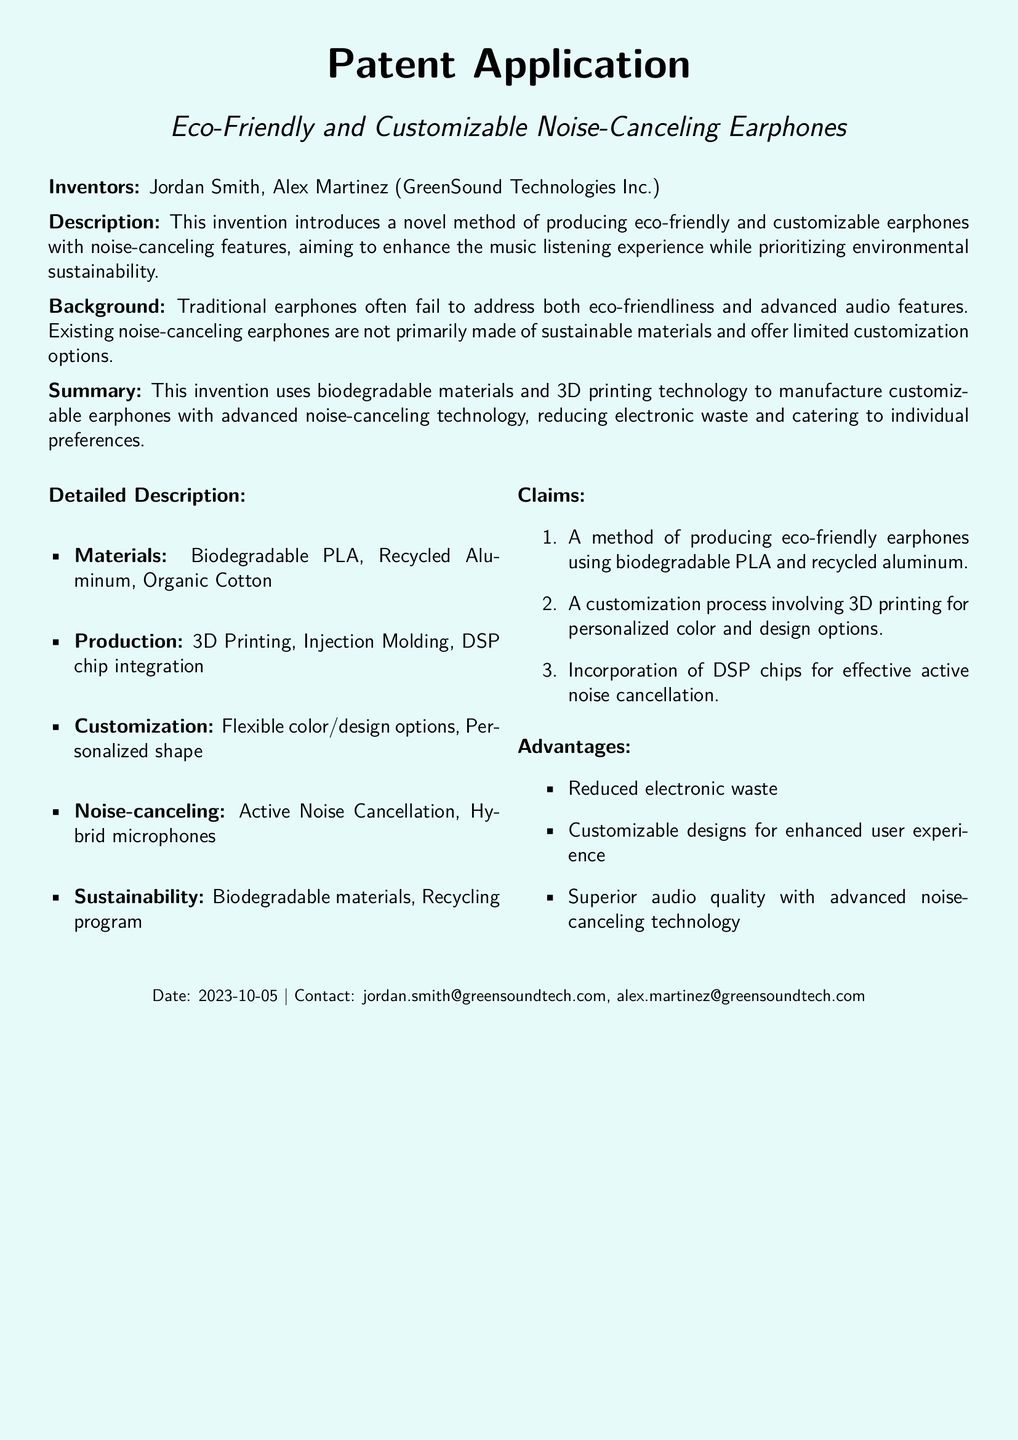What is the name of the inventors? The inventors are listed at the beginning of the document as Jordan Smith and Alex Martinez.
Answer: Jordan Smith, Alex Martinez What materials are used for production? The document specifically mentions biodegradable PLA, recycled aluminum, and organic cotton as materials.
Answer: Biodegradable PLA, Recycled Aluminum, Organic Cotton What is the date of the patent application? The date is stated at the bottom of the document along with the contact information.
Answer: 2023-10-05 What technology is used to manufacture the earphones? The document highlights the use of 3D printing technology in the production process.
Answer: 3D Printing How many claims are made in this patent application? The document lists three claims under the claims section.
Answer: Three What is the primary aim of this invention? The aim is highlighted in the description as enhancing the music listening experience while prioritizing environmental sustainability.
Answer: Enhance music listening experience What feature allows for customization? The customization is enabled through the 3D printing process mentioned in the detailed description.
Answer: 3D printing What does DSP stand for in this application? The document refers to DSP in relation to chip integration for noise cancellation but does not spell it out.
Answer: DSP What is one advantage of using biodegradable materials? The document states that using biodegradable materials leads to reduced electronic waste.
Answer: Reduced electronic waste 